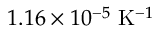<formula> <loc_0><loc_0><loc_500><loc_500>1 . 1 6 \times 1 0 ^ { - 5 } K ^ { - 1 }</formula> 